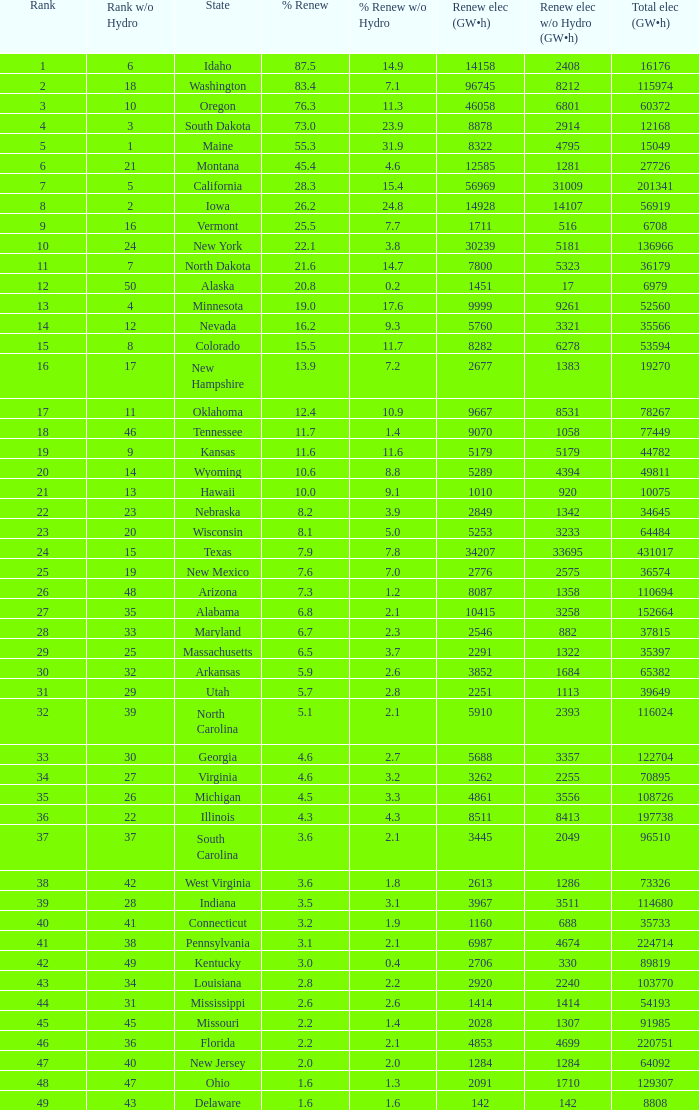Could you parse the entire table? {'header': ['Rank', 'Rank w/o Hydro', 'State', '% Renew', '% Renew w/o Hydro', 'Renew elec (GW•h)', 'Renew elec w/o Hydro (GW•h)', 'Total elec (GW•h)'], 'rows': [['1', '6', 'Idaho', '87.5', '14.9', '14158', '2408', '16176'], ['2', '18', 'Washington', '83.4', '7.1', '96745', '8212', '115974'], ['3', '10', 'Oregon', '76.3', '11.3', '46058', '6801', '60372'], ['4', '3', 'South Dakota', '73.0', '23.9', '8878', '2914', '12168'], ['5', '1', 'Maine', '55.3', '31.9', '8322', '4795', '15049'], ['6', '21', 'Montana', '45.4', '4.6', '12585', '1281', '27726'], ['7', '5', 'California', '28.3', '15.4', '56969', '31009', '201341'], ['8', '2', 'Iowa', '26.2', '24.8', '14928', '14107', '56919'], ['9', '16', 'Vermont', '25.5', '7.7', '1711', '516', '6708'], ['10', '24', 'New York', '22.1', '3.8', '30239', '5181', '136966'], ['11', '7', 'North Dakota', '21.6', '14.7', '7800', '5323', '36179'], ['12', '50', 'Alaska', '20.8', '0.2', '1451', '17', '6979'], ['13', '4', 'Minnesota', '19.0', '17.6', '9999', '9261', '52560'], ['14', '12', 'Nevada', '16.2', '9.3', '5760', '3321', '35566'], ['15', '8', 'Colorado', '15.5', '11.7', '8282', '6278', '53594'], ['16', '17', 'New Hampshire', '13.9', '7.2', '2677', '1383', '19270'], ['17', '11', 'Oklahoma', '12.4', '10.9', '9667', '8531', '78267'], ['18', '46', 'Tennessee', '11.7', '1.4', '9070', '1058', '77449'], ['19', '9', 'Kansas', '11.6', '11.6', '5179', '5179', '44782'], ['20', '14', 'Wyoming', '10.6', '8.8', '5289', '4394', '49811'], ['21', '13', 'Hawaii', '10.0', '9.1', '1010', '920', '10075'], ['22', '23', 'Nebraska', '8.2', '3.9', '2849', '1342', '34645'], ['23', '20', 'Wisconsin', '8.1', '5.0', '5253', '3233', '64484'], ['24', '15', 'Texas', '7.9', '7.8', '34207', '33695', '431017'], ['25', '19', 'New Mexico', '7.6', '7.0', '2776', '2575', '36574'], ['26', '48', 'Arizona', '7.3', '1.2', '8087', '1358', '110694'], ['27', '35', 'Alabama', '6.8', '2.1', '10415', '3258', '152664'], ['28', '33', 'Maryland', '6.7', '2.3', '2546', '882', '37815'], ['29', '25', 'Massachusetts', '6.5', '3.7', '2291', '1322', '35397'], ['30', '32', 'Arkansas', '5.9', '2.6', '3852', '1684', '65382'], ['31', '29', 'Utah', '5.7', '2.8', '2251', '1113', '39649'], ['32', '39', 'North Carolina', '5.1', '2.1', '5910', '2393', '116024'], ['33', '30', 'Georgia', '4.6', '2.7', '5688', '3357', '122704'], ['34', '27', 'Virginia', '4.6', '3.2', '3262', '2255', '70895'], ['35', '26', 'Michigan', '4.5', '3.3', '4861', '3556', '108726'], ['36', '22', 'Illinois', '4.3', '4.3', '8511', '8413', '197738'], ['37', '37', 'South Carolina', '3.6', '2.1', '3445', '2049', '96510'], ['38', '42', 'West Virginia', '3.6', '1.8', '2613', '1286', '73326'], ['39', '28', 'Indiana', '3.5', '3.1', '3967', '3511', '114680'], ['40', '41', 'Connecticut', '3.2', '1.9', '1160', '688', '35733'], ['41', '38', 'Pennsylvania', '3.1', '2.1', '6987', '4674', '224714'], ['42', '49', 'Kentucky', '3.0', '0.4', '2706', '330', '89819'], ['43', '34', 'Louisiana', '2.8', '2.2', '2920', '2240', '103770'], ['44', '31', 'Mississippi', '2.6', '2.6', '1414', '1414', '54193'], ['45', '45', 'Missouri', '2.2', '1.4', '2028', '1307', '91985'], ['46', '36', 'Florida', '2.2', '2.1', '4853', '4699', '220751'], ['47', '40', 'New Jersey', '2.0', '2.0', '1284', '1284', '64092'], ['48', '47', 'Ohio', '1.6', '1.3', '2091', '1710', '129307'], ['49', '43', 'Delaware', '1.6', '1.6', '142', '142', '8808']]} What is the maximum renewable energy (gw×h) for the state of Delaware? 142.0. 